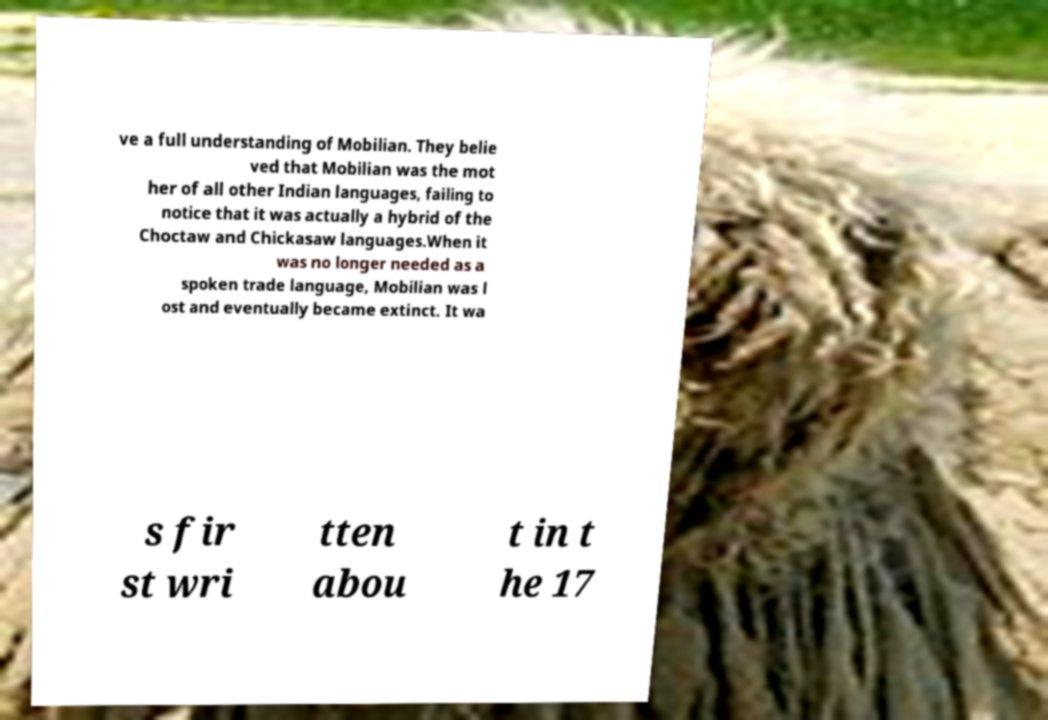Could you extract and type out the text from this image? ve a full understanding of Mobilian. They belie ved that Mobilian was the mot her of all other Indian languages, failing to notice that it was actually a hybrid of the Choctaw and Chickasaw languages.When it was no longer needed as a spoken trade language, Mobilian was l ost and eventually became extinct. It wa s fir st wri tten abou t in t he 17 